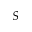<formula> <loc_0><loc_0><loc_500><loc_500>S</formula> 